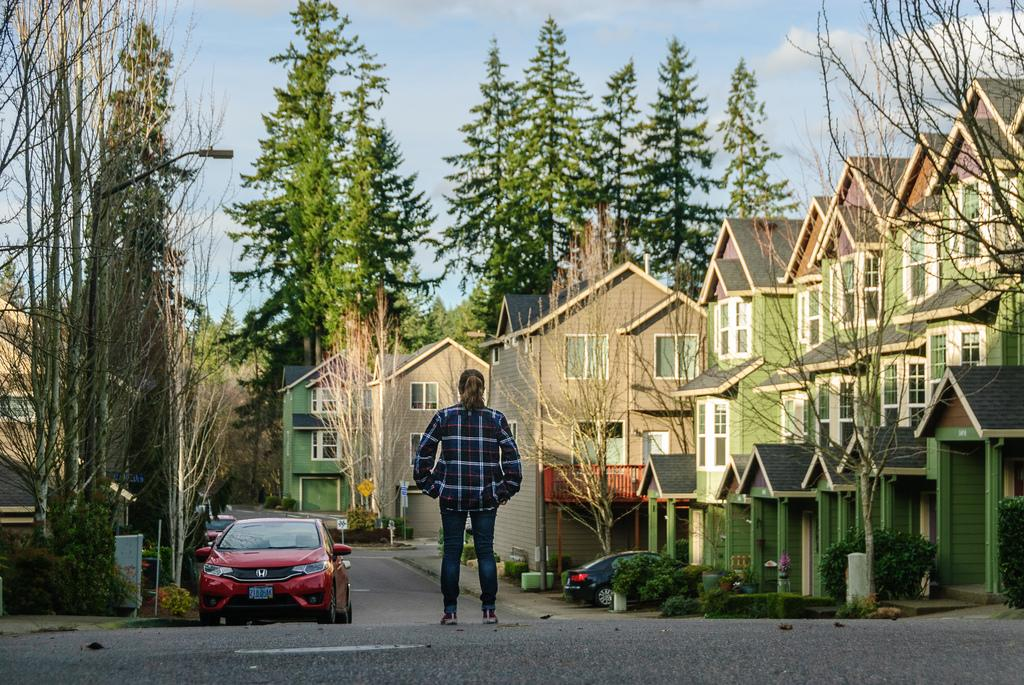What is the main subject of the image? There is a person standing in the image. What can be seen in the background of the image? The sky is visible in the background of the image. What type of structures are present in the image? There are buildings in the image. What other natural elements can be seen in the image? There are plants and trees in the image. What else is present in the image besides the person and natural elements? There are vehicles on the road in the image. What type of pies can be seen in the image? There are no pies present in the image. What is the noise level in the image? The noise level cannot be determined from the image, as it is a still photograph. 